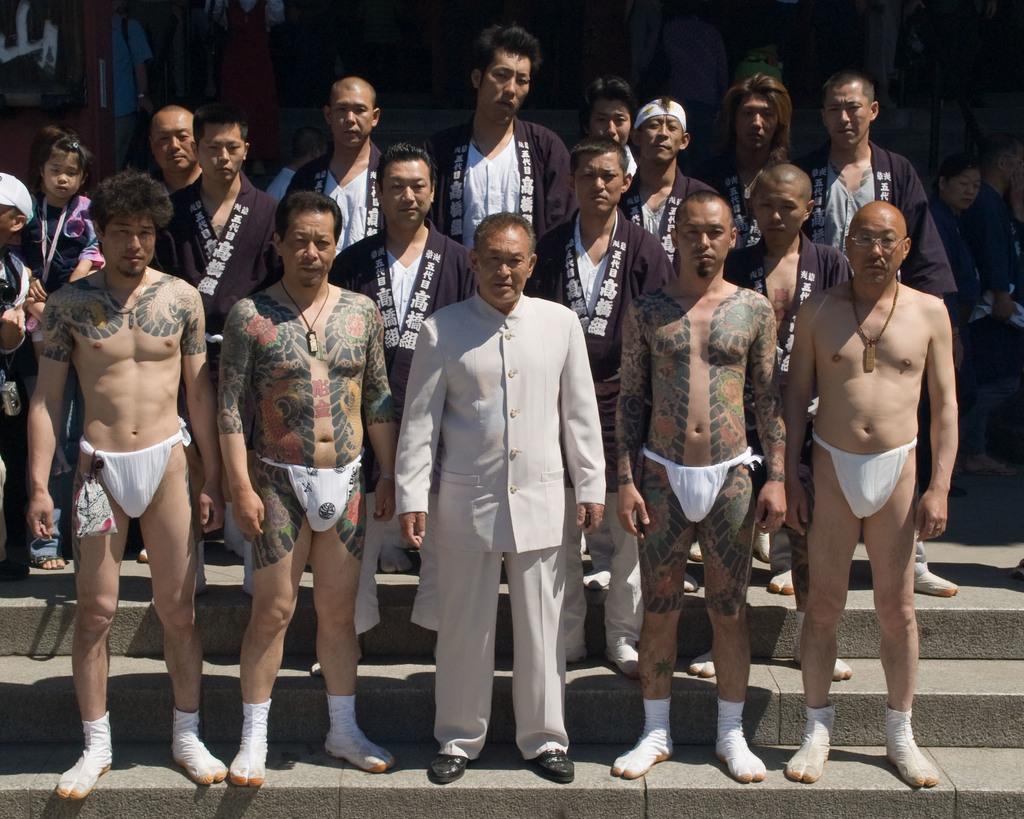Can you describe this image briefly? In this we can see many people. There are few objects at the top of the image. 